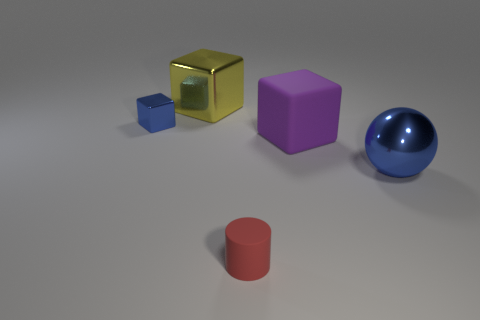Add 2 yellow rubber spheres. How many objects exist? 7 Subtract all spheres. How many objects are left? 4 Subtract all tiny spheres. Subtract all purple rubber things. How many objects are left? 4 Add 3 tiny rubber cylinders. How many tiny rubber cylinders are left? 4 Add 4 tiny matte cylinders. How many tiny matte cylinders exist? 5 Subtract 0 green cylinders. How many objects are left? 5 